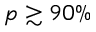<formula> <loc_0><loc_0><loc_500><loc_500>p \gtrsim 9 0 \%</formula> 